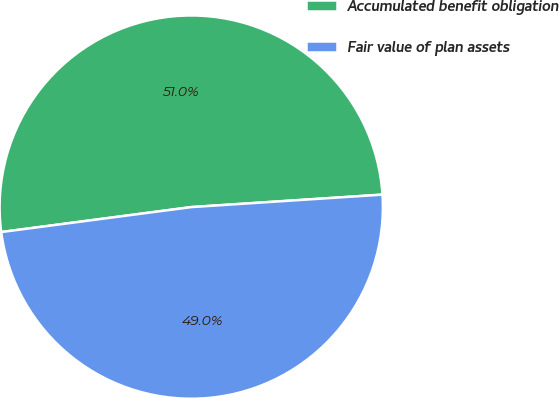Convert chart to OTSL. <chart><loc_0><loc_0><loc_500><loc_500><pie_chart><fcel>Accumulated benefit obligation<fcel>Fair value of plan assets<nl><fcel>51.04%<fcel>48.96%<nl></chart> 